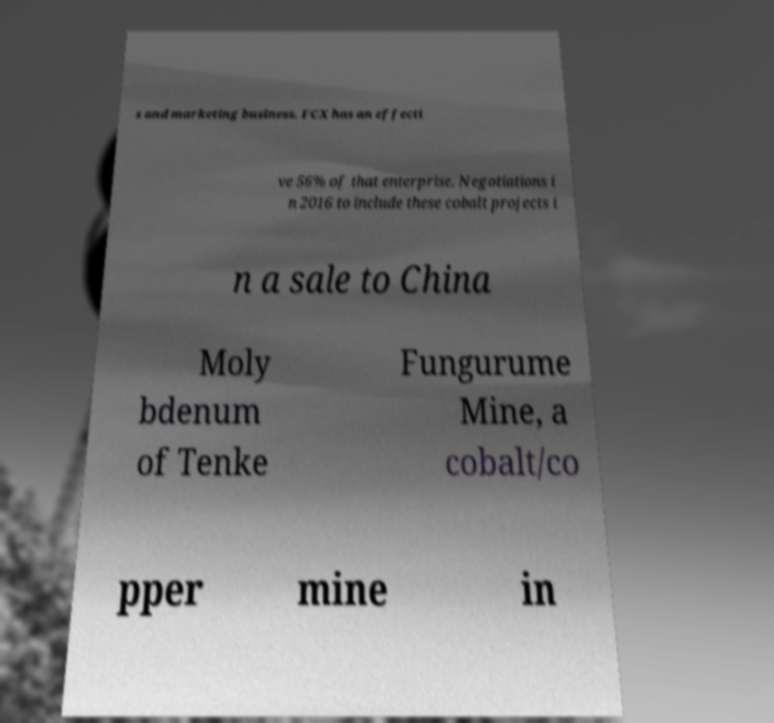What messages or text are displayed in this image? I need them in a readable, typed format. s and marketing business. FCX has an effecti ve 56% of that enterprise. Negotiations i n 2016 to include these cobalt projects i n a sale to China Moly bdenum of Tenke Fungurume Mine, a cobalt/co pper mine in 